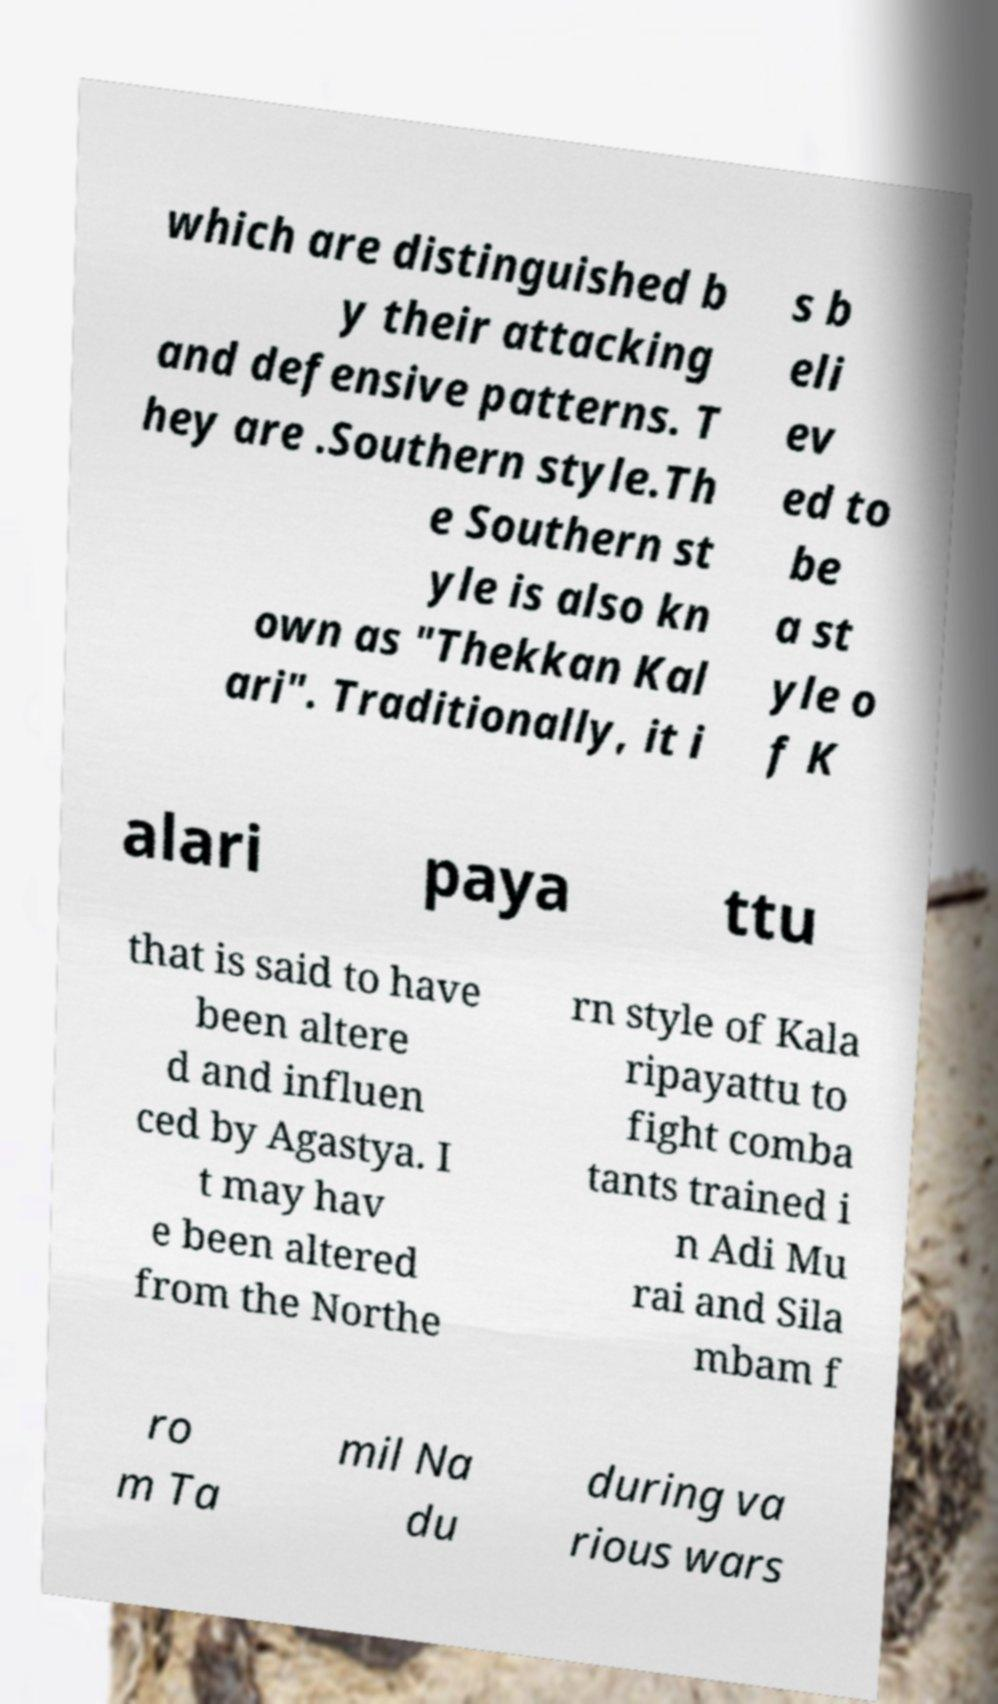Can you accurately transcribe the text from the provided image for me? which are distinguished b y their attacking and defensive patterns. T hey are .Southern style.Th e Southern st yle is also kn own as "Thekkan Kal ari". Traditionally, it i s b eli ev ed to be a st yle o f K alari paya ttu that is said to have been altere d and influen ced by Agastya. I t may hav e been altered from the Northe rn style of Kala ripayattu to fight comba tants trained i n Adi Mu rai and Sila mbam f ro m Ta mil Na du during va rious wars 